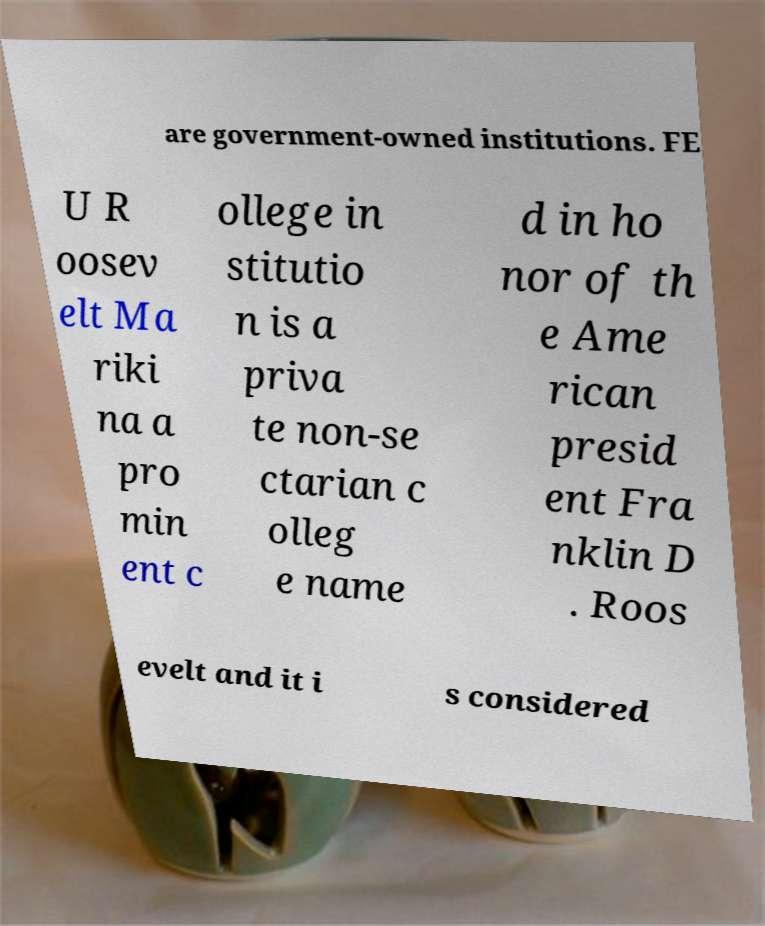For documentation purposes, I need the text within this image transcribed. Could you provide that? are government-owned institutions. FE U R oosev elt Ma riki na a pro min ent c ollege in stitutio n is a priva te non-se ctarian c olleg e name d in ho nor of th e Ame rican presid ent Fra nklin D . Roos evelt and it i s considered 